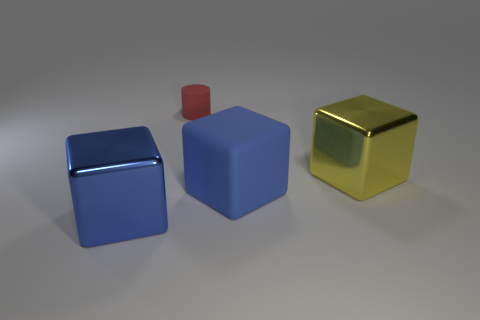Add 2 large metal objects. How many objects exist? 6 Subtract all cubes. How many objects are left? 1 Subtract 0 yellow spheres. How many objects are left? 4 Subtract all tiny green things. Subtract all matte cylinders. How many objects are left? 3 Add 2 big blocks. How many big blocks are left? 5 Add 2 big purple matte spheres. How many big purple matte spheres exist? 2 